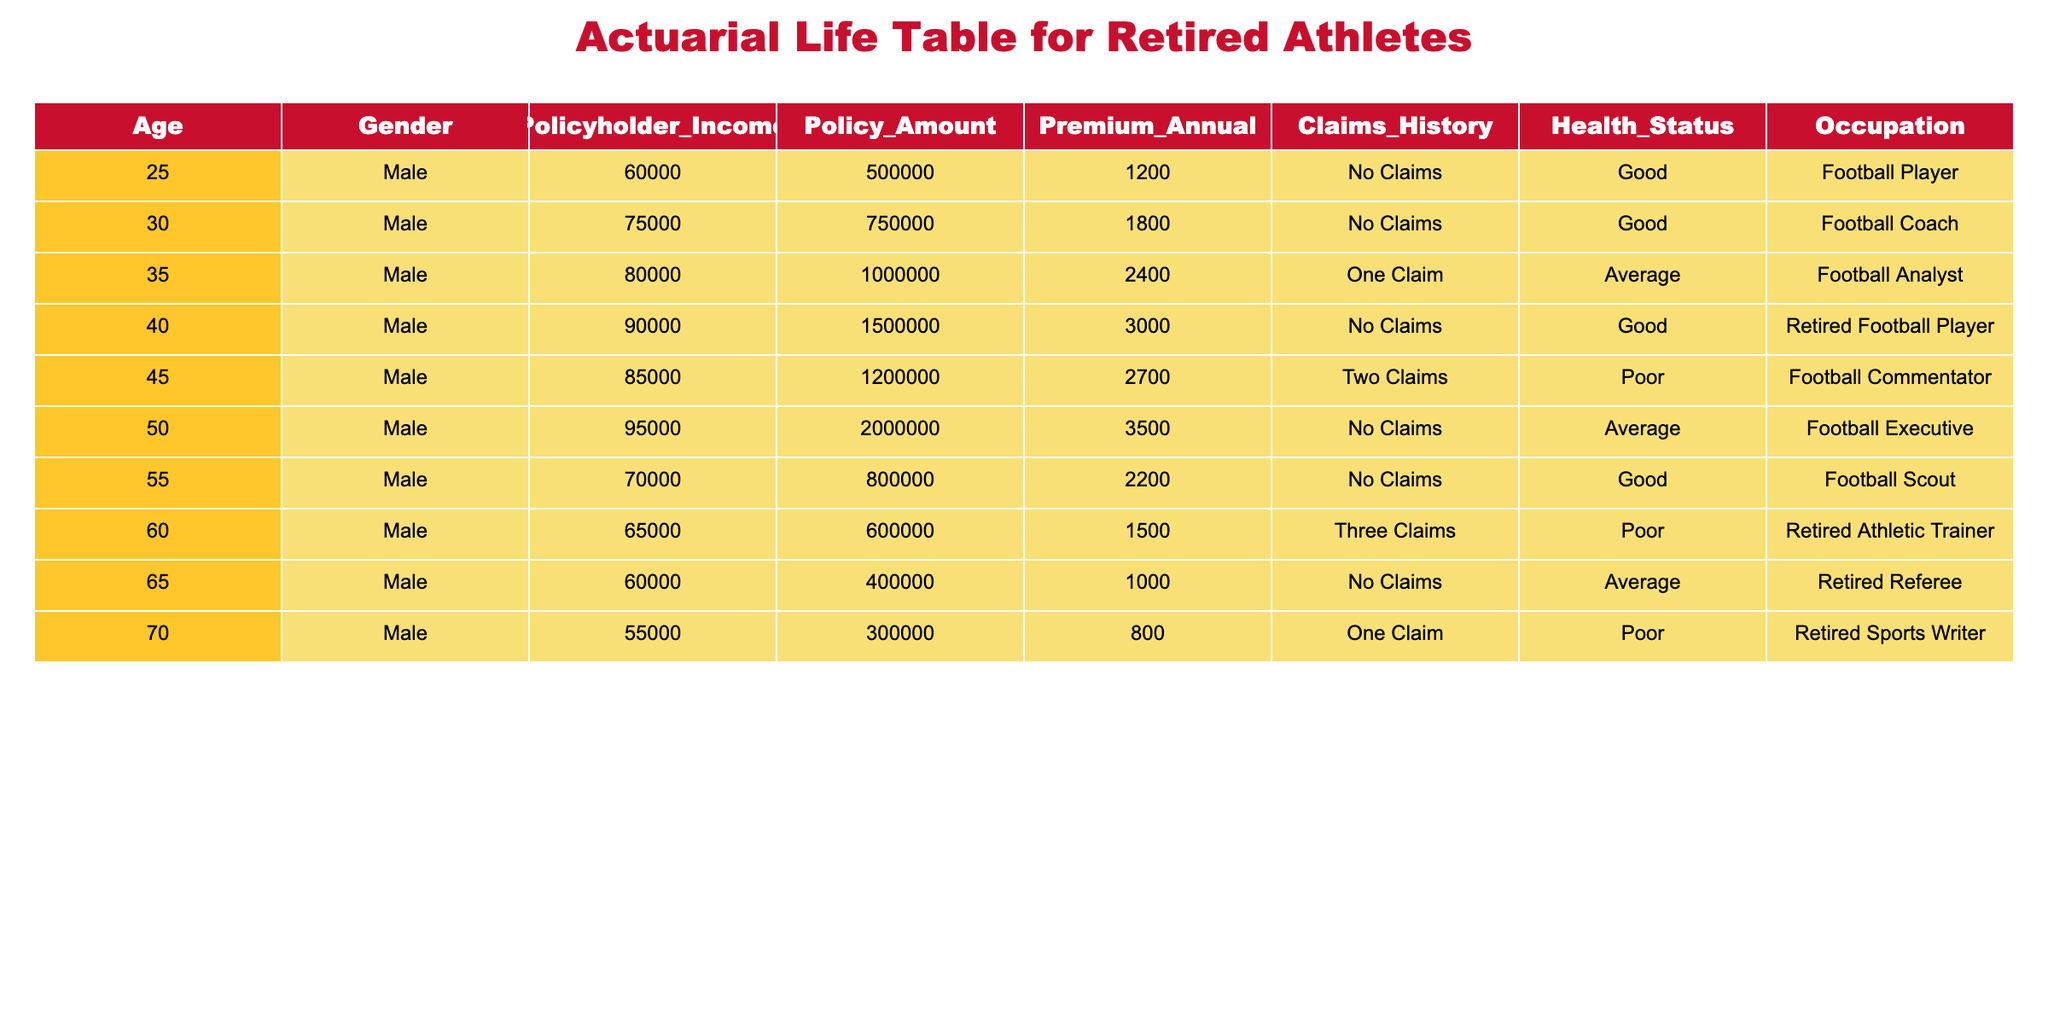What is the premium for the policyholder who is a retired football player? The table shows that the retired football player (age 40, male) has an annual premium of 3000.
Answer: 3000 What is the health status of the policyholder who is a football commentator? The table indicates that the football commentator (age 45, male) has a health status of "Poor."
Answer: Poor How many claims has the retired athletic trainer made? According to the table, the retired athletic trainer (age 60, male) has made three claims.
Answer: Three Which age group has the highest policy amount? By comparing the policy amounts, the retired football executive (age 50, male) has the highest policy amount of 2000000.
Answer: 2000000 What is the average premium for the policyholders in the table? To calculate the average premium, sum the premiums (1200 + 1800 + 2400 + 3000 + 2700 + 3500 + 2200 + 1500 + 1000 + 800) = 19900, then divide by the number of policyholders (10), so the average premium is 1990.
Answer: 1990 Is there any policyholder who has never made a claim? By reviewing the table, we can see that the retired football player, football coach, football executive, football scout, and retired referee have never made a claim, confirming that there are multiple policyholders without claims.
Answer: Yes Can you name the occupations of the policyholders with poor health status? The table shows that the occupations of policyholders with poor health status are "Football Commentator" (age 45) and "Retired Athletic Trainer" (age 60), confirming that both have poor health status.
Answer: Football Commentator, Retired Athletic Trainer Who has the highest income and what is the premium compared to the average premium? The highest income among the policyholders is 95000 (occupation: Football Executive, age 50) with a premium of 3500. The average premium calculated earlier is 1990, and the difference is 3500 - 1990 = 1510, suggesting the premium is higher than average.
Answer: 3500, higher by 1510 How many policyholders have an average health status? The table shows that there are three policyholders with average health status: the football analyst (age 35), football executive (age 50), and retired referee (age 65).
Answer: Three 